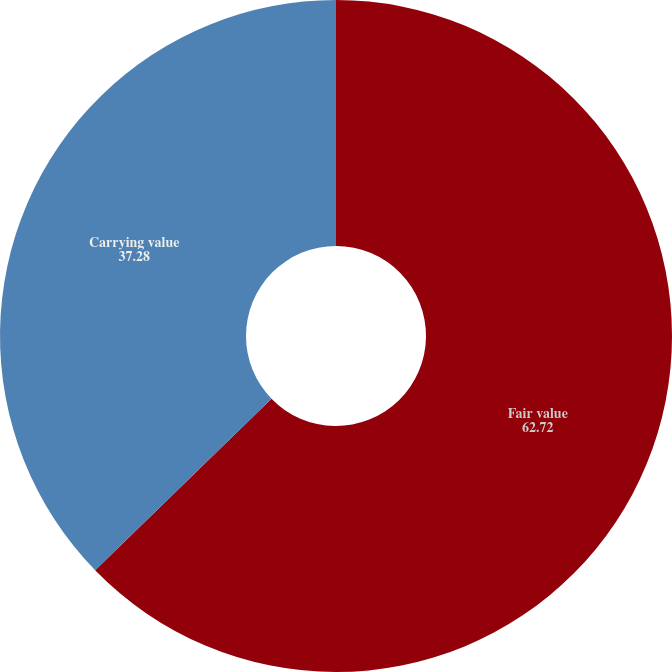Convert chart to OTSL. <chart><loc_0><loc_0><loc_500><loc_500><pie_chart><fcel>Fair value<fcel>Carrying value<nl><fcel>62.72%<fcel>37.28%<nl></chart> 